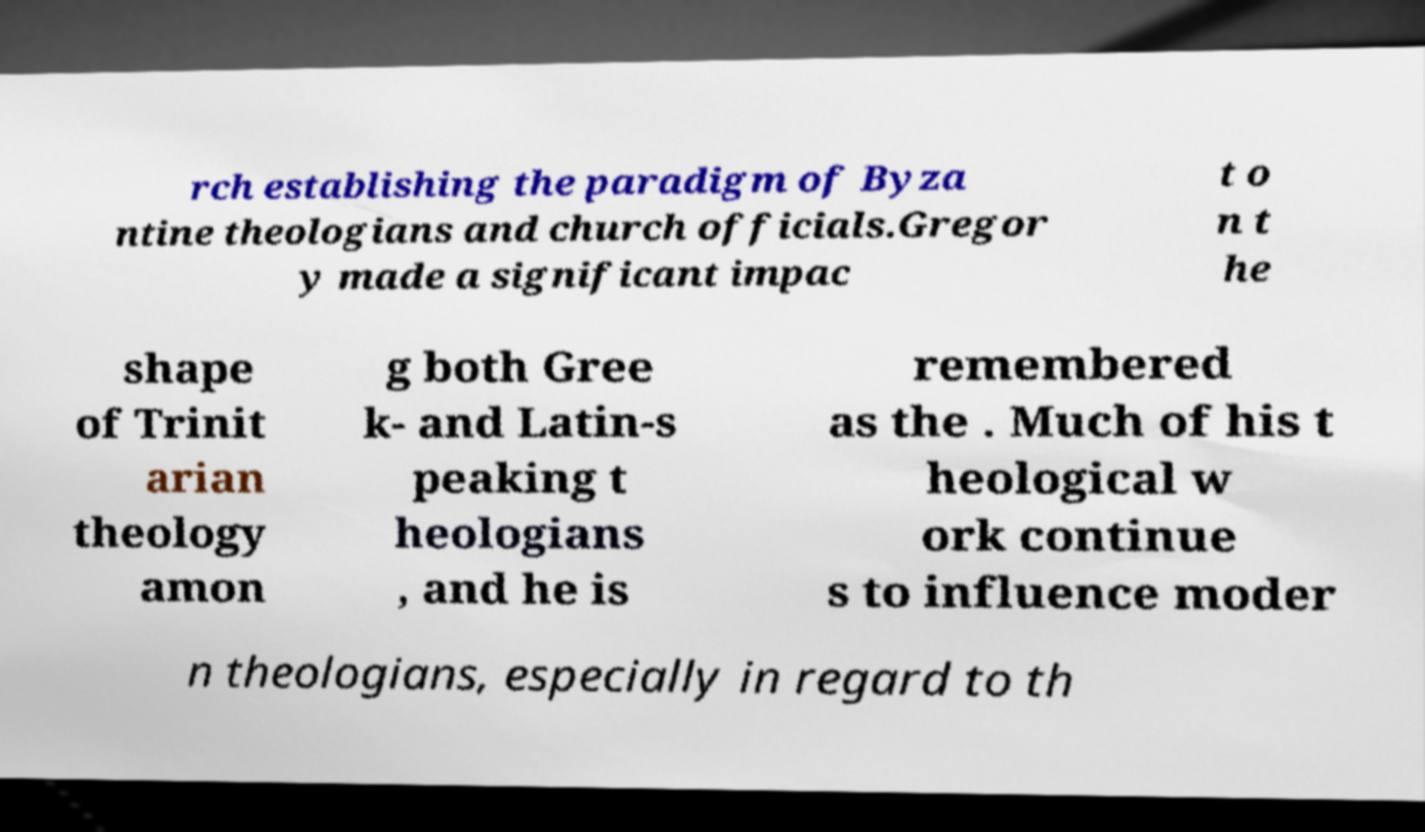Could you extract and type out the text from this image? rch establishing the paradigm of Byza ntine theologians and church officials.Gregor y made a significant impac t o n t he shape of Trinit arian theology amon g both Gree k- and Latin-s peaking t heologians , and he is remembered as the . Much of his t heological w ork continue s to influence moder n theologians, especially in regard to th 